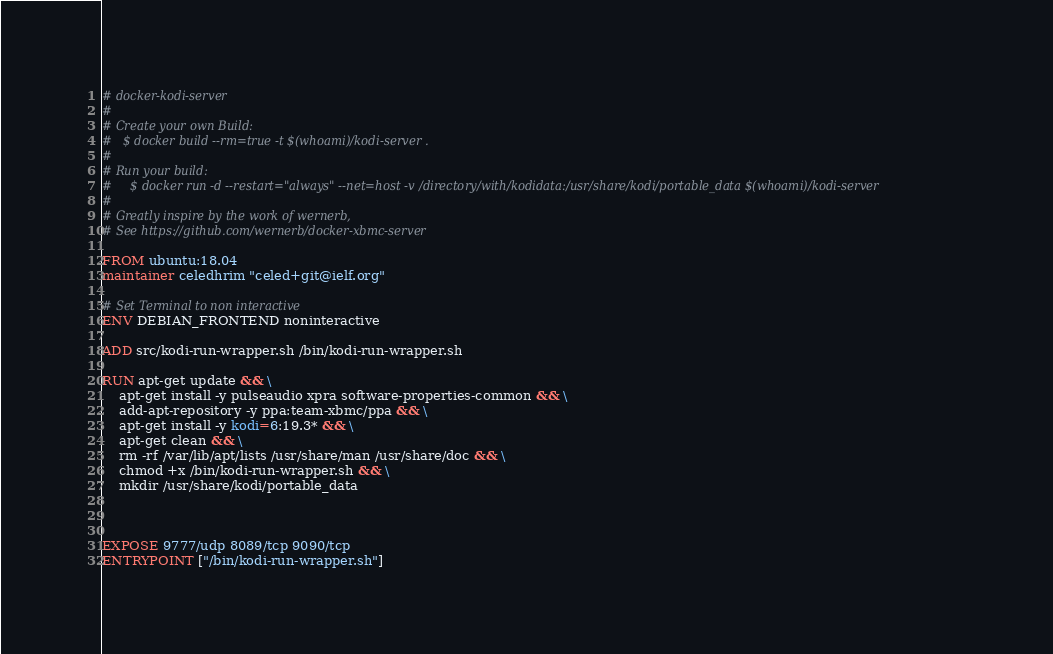<code> <loc_0><loc_0><loc_500><loc_500><_Dockerfile_># docker-kodi-server
#
# Create your own Build:
# 	$ docker build --rm=true -t $(whoami)/kodi-server .
#
# Run your build:
#	  $ docker run -d --restart="always" --net=host -v /directory/with/kodidata:/usr/share/kodi/portable_data $(whoami)/kodi-server
#
# Greatly inspire by the work of wernerb,
# See https://github.com/wernerb/docker-xbmc-server

FROM ubuntu:18.04
maintainer celedhrim "celed+git@ielf.org"

# Set Terminal to non interactive
ENV DEBIAN_FRONTEND noninteractive

ADD src/kodi-run-wrapper.sh /bin/kodi-run-wrapper.sh

RUN apt-get update && \
    apt-get install -y pulseaudio xpra software-properties-common && \
    add-apt-repository -y ppa:team-xbmc/ppa && \
    apt-get install -y kodi=6:19.3* && \
    apt-get clean && \
    rm -rf /var/lib/apt/lists /usr/share/man /usr/share/doc && \
    chmod +x /bin/kodi-run-wrapper.sh && \
    mkdir /usr/share/kodi/portable_data



EXPOSE 9777/udp 8089/tcp 9090/tcp
ENTRYPOINT ["/bin/kodi-run-wrapper.sh"]
</code> 